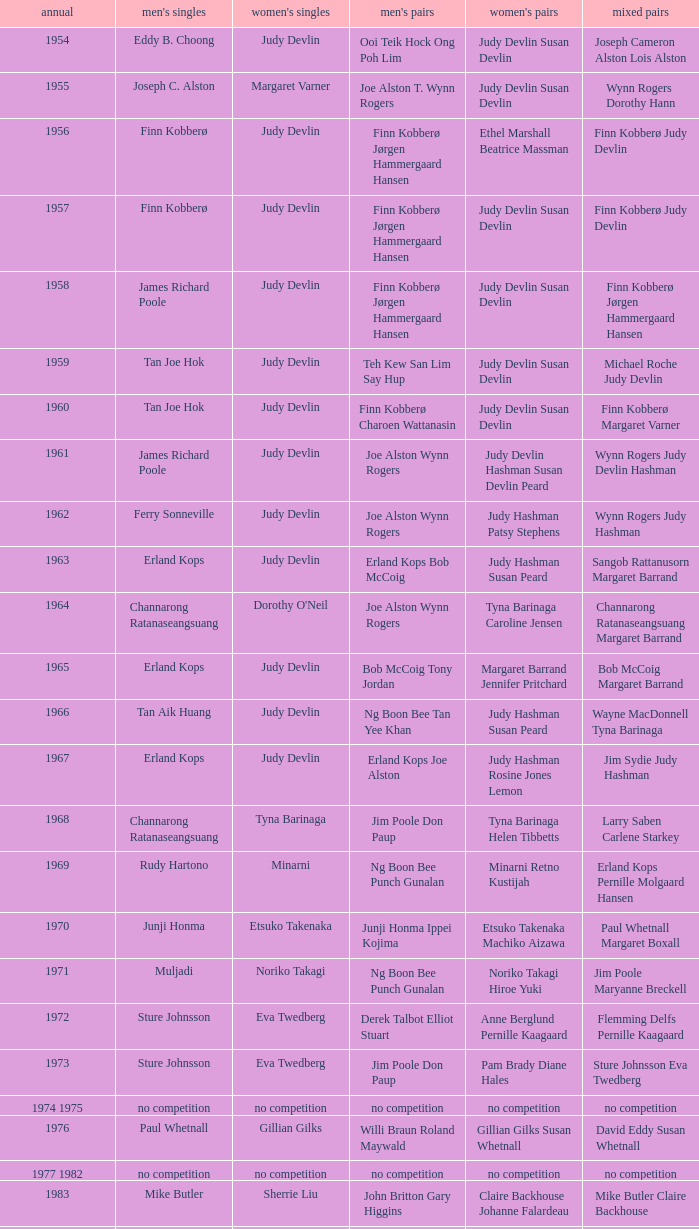Who was the women's singles champion in 1984? Luo Yun. 